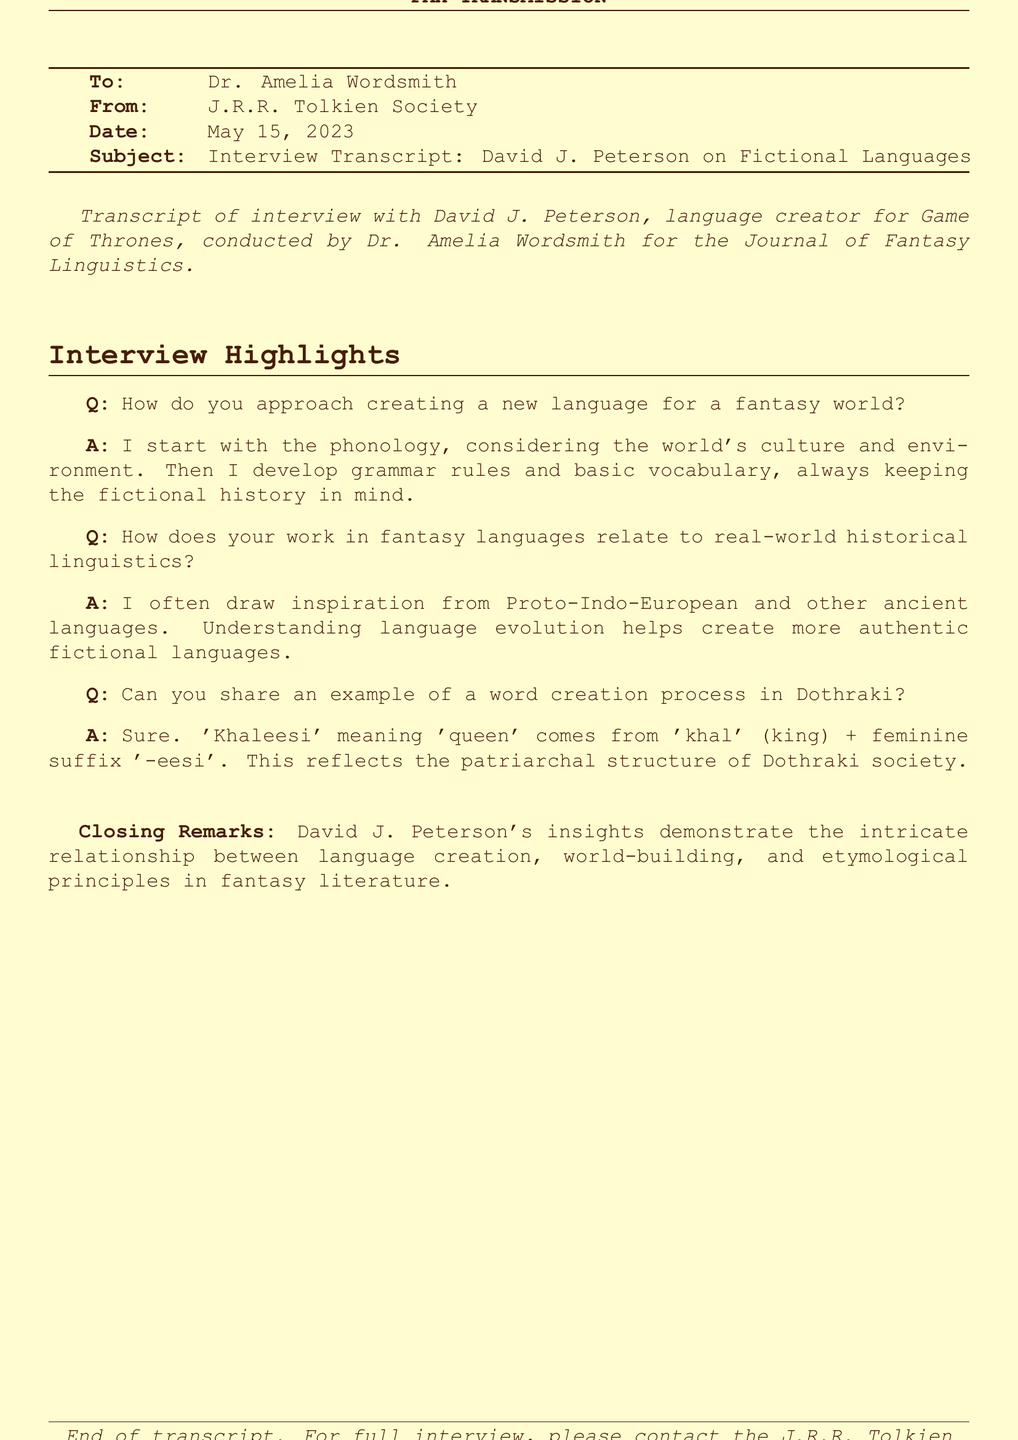What is the name of the interviewee? The interviewee is a renowned language creator for fantasy works, specifically mentioned as David J. Peterson.
Answer: David J. Peterson Who conducted the interview? The interview was conducted by Dr. Amelia Wordsmith, as per the document's information.
Answer: Dr. Amelia Wordsmith What is the subject of this fax transmission? The subject of the fax, as stated at the top, is about the interview with David J. Peterson focusing on fictional languages.
Answer: Interview Transcript: David J. Peterson on Fictional Languages When was the interview conducted? The date provided in the document indicates when the fax was sent, which is relevant to the interview's timeline.
Answer: May 15, 2023 What language does 'Khaleesi' originate from? The word 'Khaleesi' is derived as an example from the Dothraki language discussed in the interview.
Answer: Dothraki What foundational language inspires Peterson’s language creation? The document mentions that Peterson draws inspiration from historical languages, particularly pointing out one ancient language that is foundational to his work.
Answer: Proto-Indo-European What key element does Peterson start with when creating a language? The earliest step in Peterson's language creation process focuses on an important linguistic aspect that defines how sound is structured in a new language.
Answer: Phonology What unique structure does 'Khaleesi' reflect in Dothraki society? The construction of the word 'Khaleesi' indicates a specific societal structure, which is part of Dothraki's cultural perception.
Answer: Patriarchal structure 